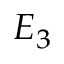Convert formula to latex. <formula><loc_0><loc_0><loc_500><loc_500>E _ { 3 }</formula> 